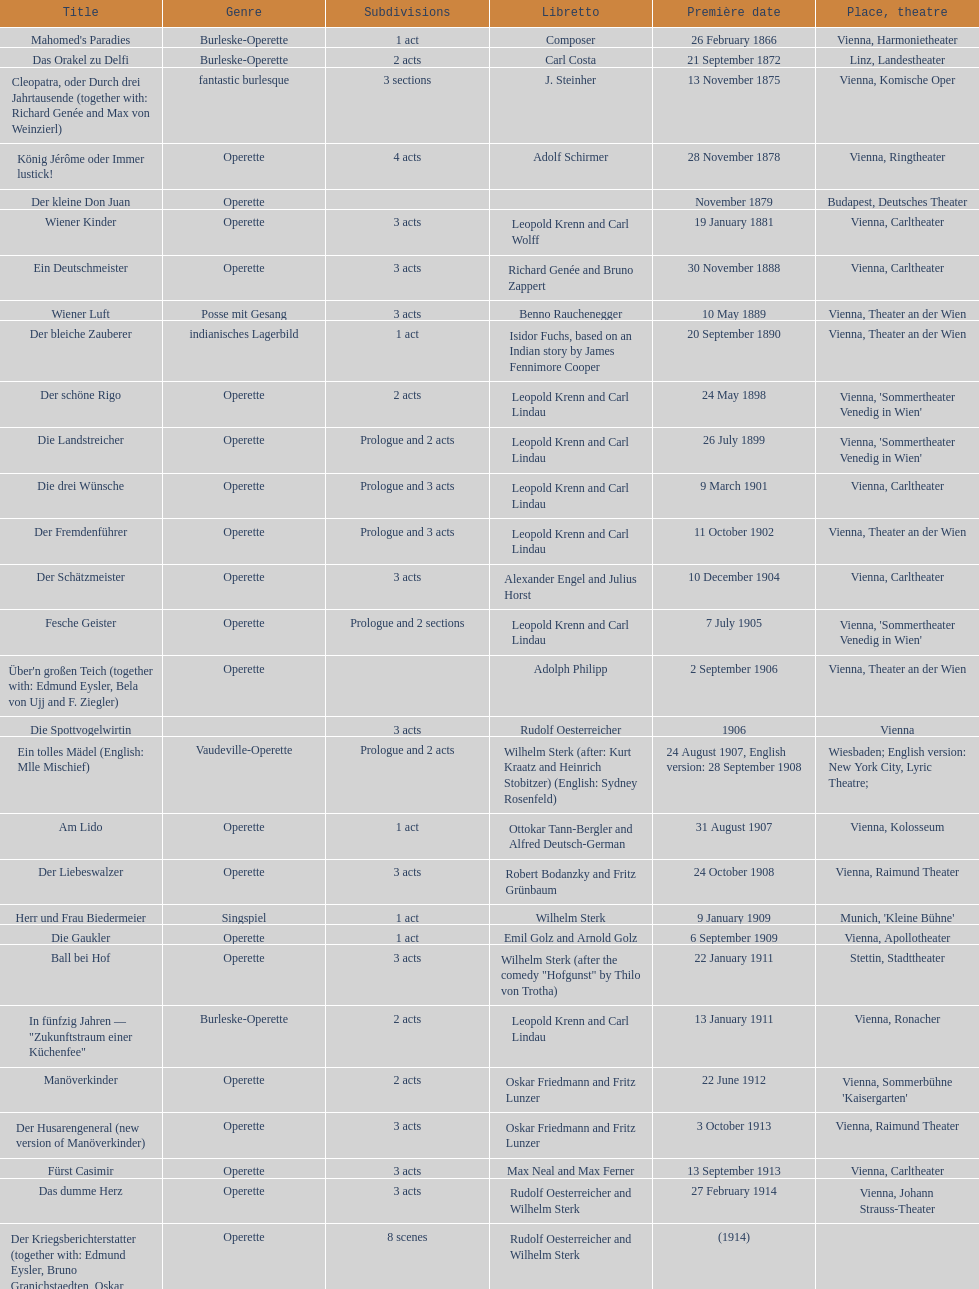What are the number of titles that premiered in the month of september? 4. 